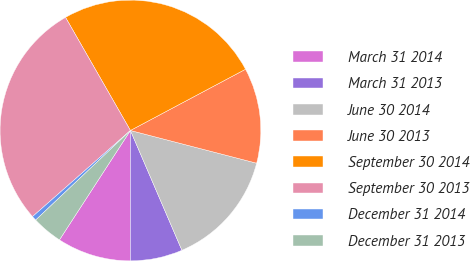Convert chart. <chart><loc_0><loc_0><loc_500><loc_500><pie_chart><fcel>March 31 2014<fcel>March 31 2013<fcel>June 30 2014<fcel>June 30 2013<fcel>September 30 2014<fcel>September 30 2013<fcel>December 31 2014<fcel>December 31 2013<nl><fcel>9.15%<fcel>6.47%<fcel>14.5%<fcel>11.82%<fcel>25.51%<fcel>28.19%<fcel>0.57%<fcel>3.79%<nl></chart> 